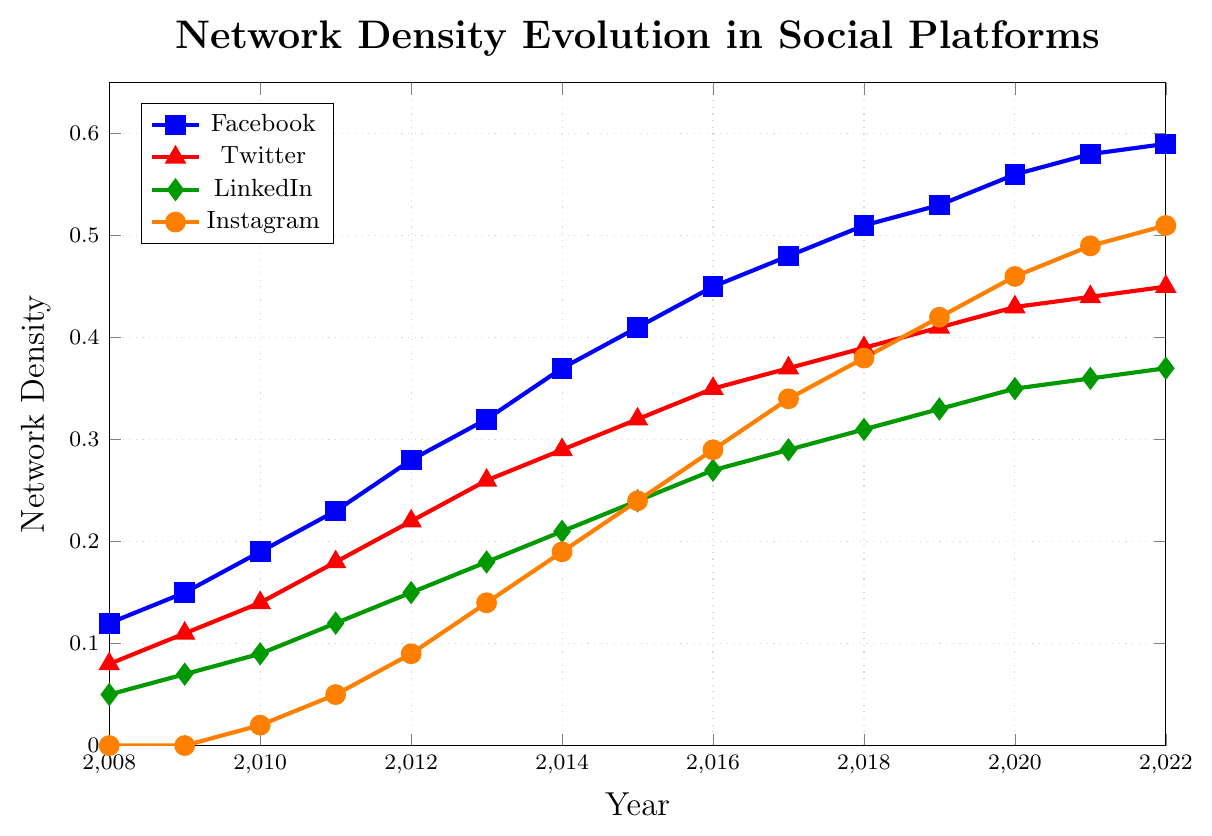Which social platform had the highest network density in 2010? The plot shows four lines representing different social platforms: Facebook, Twitter, LinkedIn, and Instagram. In 2010, we can see that the line for Facebook is the highest.
Answer: Facebook How did Instagram's network density change from 2010 to 2020? To determine the change, we find the density values for Instagram in 2010 and 2020 from the plot and compute their difference. In 2010, the density is 0.02, and in 2020, it is 0.46. The change is 0.46 - 0.02.
Answer: Increased by 0.44 Which year did LinkedIn reach a network density of 0.3? To find the year LinkedIn's network density reached 0.3, we look at the green line representing LinkedIn on the plot. LinkedIn hits 0.3 between 2016 and 2017, not reaching exactly 0.3 in any given year.
Answer: Did not reach exactly 0.3 Compare the growth rate of network density between Facebook and Twitter from 2008 to 2012. For both platforms, find the density values in 2008 and 2012 and calculate the difference. Facebook's growth: 0.28 - 0.12 = 0.16. Twitter's growth: 0.22 - 0.08 = 0.14. Compare these values.
Answer: Facebook grew faster Which two platforms showed equal network density in any given year, and when did that occur? By inspecting the plot, we see if any lines intersect at any point. Facebook and Instagram have equal network density in 2021 (0.49).
Answer: 2021 (Facebook and Instagram) What is the average network density of Twitter from 2010 to 2020? Sum the network density values for Twitter from 2010 to 2020, then divide by the number of years. (0.14 + 0.18 + 0.22 + 0.26 + 0.29 + 0.32 + 0.35 + 0.37 + 0.39 + 0.41 + 0.43) / 11
Answer: 0.308 In which year did Facebook reach a network density of 0.4? Locate the point where Facebook's network density reaches 0.4 on the plot. Facebook's density reaches 0.4 during 2015.
Answer: 2015 How does Instagram's network density in 2022 compare to LinkedIn's in 2022? Look at the plot for both platforms in 2022. Instagram has a density of 0.51, while LinkedIn has a density of 0.37. Compare these densities.
Answer: Instagram is higher By how much did LinkedIn's network density increase from 2011 to 2013? Find the network density for LinkedIn in 2011 and 2013. The values are 0.12 and 0.18 respectively. Calculate the difference: 0.18 - 0.12.
Answer: Increased by 0.06 Which social platform showed the most significant increase in network density between 2008 and 2022? Calculate the difference between the network density values in 2008 and 2022 for each platform. Facebook: 0.59 - 0.12 = 0.47, Twitter: 0.45 - 0.08 = 0.37, LinkedIn: 0.37 - 0.05 = 0.32, Instagram: 0.51 - 0 = 0.51. The platform with the highest difference is Instagram.
Answer: Instagram 